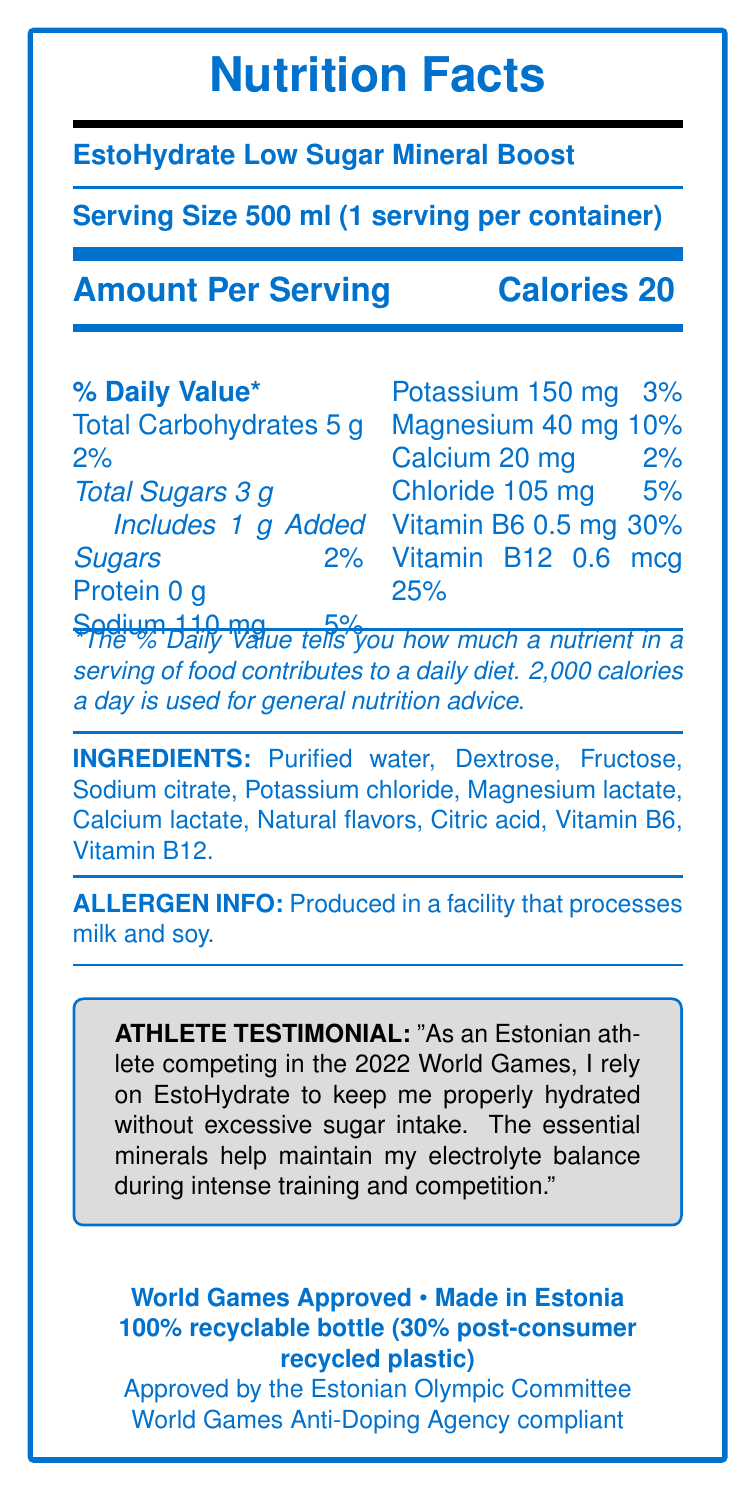What is the serving size of EstoHydrate Low Sugar Mineral Boost? The serving size is clearly stated at the top of the document as "Serving Size 500 ml (1 serving per container)".
Answer: 500 ml How many grams of total sugars are in one serving? The amount of total sugars per serving is shown under the "Total Carbohydrates" section as "Total Sugars 3 g".
Answer: 3 g How many calories are there per serving? The number of calories per serving is listed directly under "Amount Per Serving" as "Calories 20".
Answer: 20 What is the percent daily value of sodium per serving? The percent daily value for sodium per serving is listed as "Sodium 110 mg" and "5%".
Answer: 5% Does the drink contain any added sugars? Under "Total Sugars", there is a notation of "Includes 1 g Added Sugars 2%", indicating the presence of added sugars.
Answer: Yes Which mineral has the highest percent daily value in EstoHydrate Low Sugar Mineral Boost? A. Sodium B. Potassium C. Magnesium D. Calcium The document lists "Magnesium 40 mg 10%", which is the highest percent daily value compared to sodium, potassium, and calcium.
Answer: C What is the source of chloride in the drink? A. Sodium chloride B. Potassium chloride C. Magnesium chloride D. Calcium chloride "Chloride 105 mg 5%" is one nutrient, and "Potassium chloride" listed among ingredients suggests the source as potassium chloride.
Answer: B Is EstoHydrate Low Sugar Mineral Boost approved by the Estonian Olympic Committee? The bottom section states, "Approved by the Estonian Olympic Committee."
Answer: Yes Describe the main idea of the document. The document provides detailed nutrition facts, ingredients, and certifications emphasizing the drink's suitability for athlete hydration with low sugar content.
Answer: EstoHydrate Low Sugar Mineral Boost is a hydration drink with low sugar content and essential minerals, approved for athletes and containing vitamins B6 and B12. It is made in Estonia, World Games approved, and comes in sustainable packaging. Is there enough information to determine if the product is gluten-free? The document does not specify whether the product is gluten-free. It only mentions the allergen information related to milk and soy.
Answer: Not enough information What percentage of the bottle's plastic is from post-consumer recycled material? The document notes "30% post-consumer recycled plastic" under the sustainability section.
Answer: 30% Does the product have any protein in it? The "Protein" section lists "0 g", indicating there are no proteins in the product.
Answer: No What is the allergen information stated in the document? The allergen information is clearly listed as "Produced in a facility that processes milk and soy."
Answer: Produced in a facility that processes milk and soy. How many milligrams of vitamin B6 are in one serving, and what percent daily value does this represent? Vitamin B6 is listed with "0.5 mg" and "30%" in the document.
Answer: 0.5 mg, 30% Based on the athlete testimonial, why does the athlete rely on EstoHydrate? The testimonial quotes, "I rely on EstoHydrate to keep me properly hydrated without excessive sugar intake. The essential minerals help maintain my electrolyte balance during intense training and competition."
Answer: To stay hydrated without excessive sugar and to maintain electrolyte balance during intense training and competition. 